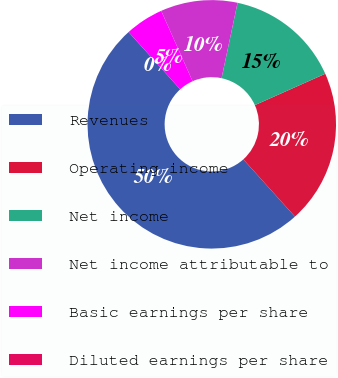Convert chart. <chart><loc_0><loc_0><loc_500><loc_500><pie_chart><fcel>Revenues<fcel>Operating income<fcel>Net income<fcel>Net income attributable to<fcel>Basic earnings per share<fcel>Diluted earnings per share<nl><fcel>50.0%<fcel>20.0%<fcel>15.0%<fcel>10.0%<fcel>5.0%<fcel>0.0%<nl></chart> 